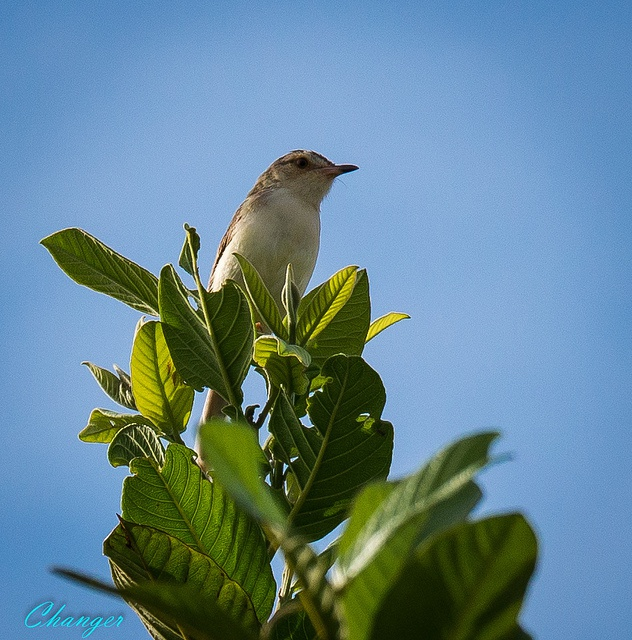Describe the objects in this image and their specific colors. I can see a bird in gray, darkgreen, tan, and black tones in this image. 